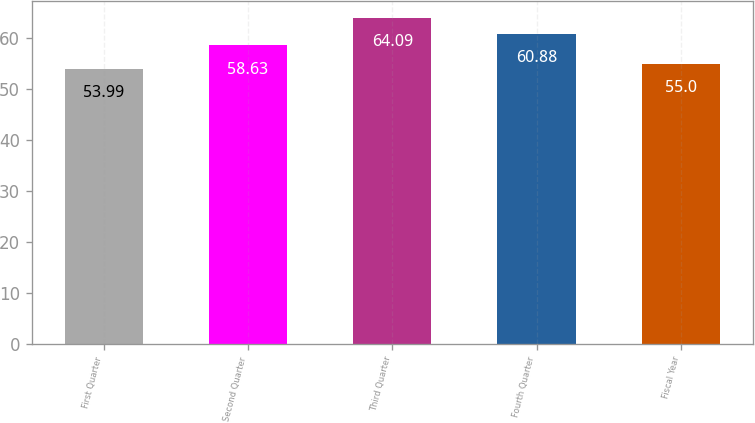<chart> <loc_0><loc_0><loc_500><loc_500><bar_chart><fcel>First Quarter<fcel>Second Quarter<fcel>Third Quarter<fcel>Fourth Quarter<fcel>Fiscal Year<nl><fcel>53.99<fcel>58.63<fcel>64.09<fcel>60.88<fcel>55<nl></chart> 